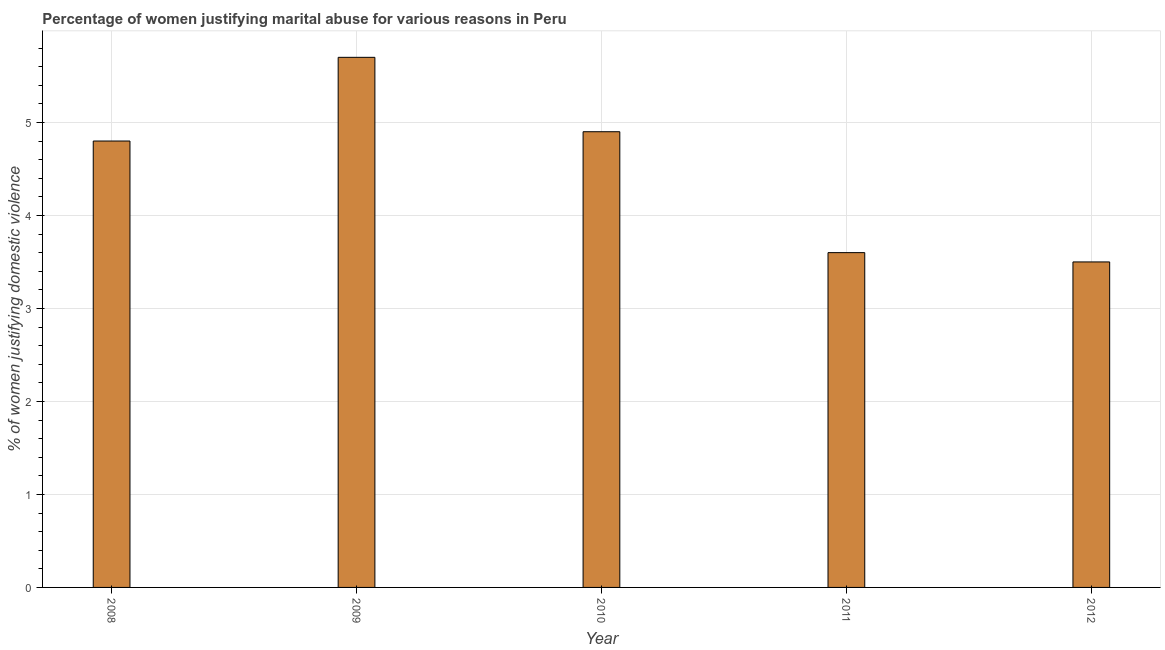Does the graph contain any zero values?
Your answer should be very brief. No. Does the graph contain grids?
Make the answer very short. Yes. What is the title of the graph?
Make the answer very short. Percentage of women justifying marital abuse for various reasons in Peru. What is the label or title of the Y-axis?
Give a very brief answer. % of women justifying domestic violence. Across all years, what is the maximum percentage of women justifying marital abuse?
Provide a short and direct response. 5.7. In which year was the percentage of women justifying marital abuse minimum?
Keep it short and to the point. 2012. What is the sum of the percentage of women justifying marital abuse?
Provide a short and direct response. 22.5. What is the average percentage of women justifying marital abuse per year?
Offer a very short reply. 4.5. In how many years, is the percentage of women justifying marital abuse greater than 5 %?
Keep it short and to the point. 1. Do a majority of the years between 2010 and 2012 (inclusive) have percentage of women justifying marital abuse greater than 2.8 %?
Provide a succinct answer. Yes. What is the ratio of the percentage of women justifying marital abuse in 2008 to that in 2012?
Offer a very short reply. 1.37. Is the percentage of women justifying marital abuse in 2008 less than that in 2012?
Offer a terse response. No. Is the difference between the percentage of women justifying marital abuse in 2010 and 2011 greater than the difference between any two years?
Offer a terse response. No. What is the difference between the highest and the second highest percentage of women justifying marital abuse?
Offer a very short reply. 0.8. Is the sum of the percentage of women justifying marital abuse in 2009 and 2012 greater than the maximum percentage of women justifying marital abuse across all years?
Ensure brevity in your answer.  Yes. How many years are there in the graph?
Provide a short and direct response. 5. What is the difference between two consecutive major ticks on the Y-axis?
Give a very brief answer. 1. What is the % of women justifying domestic violence in 2008?
Keep it short and to the point. 4.8. What is the % of women justifying domestic violence in 2009?
Ensure brevity in your answer.  5.7. What is the % of women justifying domestic violence in 2011?
Provide a short and direct response. 3.6. What is the % of women justifying domestic violence in 2012?
Give a very brief answer. 3.5. What is the difference between the % of women justifying domestic violence in 2008 and 2010?
Offer a very short reply. -0.1. What is the difference between the % of women justifying domestic violence in 2008 and 2011?
Offer a terse response. 1.2. What is the difference between the % of women justifying domestic violence in 2008 and 2012?
Your answer should be very brief. 1.3. What is the difference between the % of women justifying domestic violence in 2010 and 2011?
Provide a succinct answer. 1.3. What is the difference between the % of women justifying domestic violence in 2010 and 2012?
Keep it short and to the point. 1.4. What is the ratio of the % of women justifying domestic violence in 2008 to that in 2009?
Keep it short and to the point. 0.84. What is the ratio of the % of women justifying domestic violence in 2008 to that in 2010?
Make the answer very short. 0.98. What is the ratio of the % of women justifying domestic violence in 2008 to that in 2011?
Keep it short and to the point. 1.33. What is the ratio of the % of women justifying domestic violence in 2008 to that in 2012?
Provide a succinct answer. 1.37. What is the ratio of the % of women justifying domestic violence in 2009 to that in 2010?
Keep it short and to the point. 1.16. What is the ratio of the % of women justifying domestic violence in 2009 to that in 2011?
Your response must be concise. 1.58. What is the ratio of the % of women justifying domestic violence in 2009 to that in 2012?
Ensure brevity in your answer.  1.63. What is the ratio of the % of women justifying domestic violence in 2010 to that in 2011?
Your response must be concise. 1.36. 